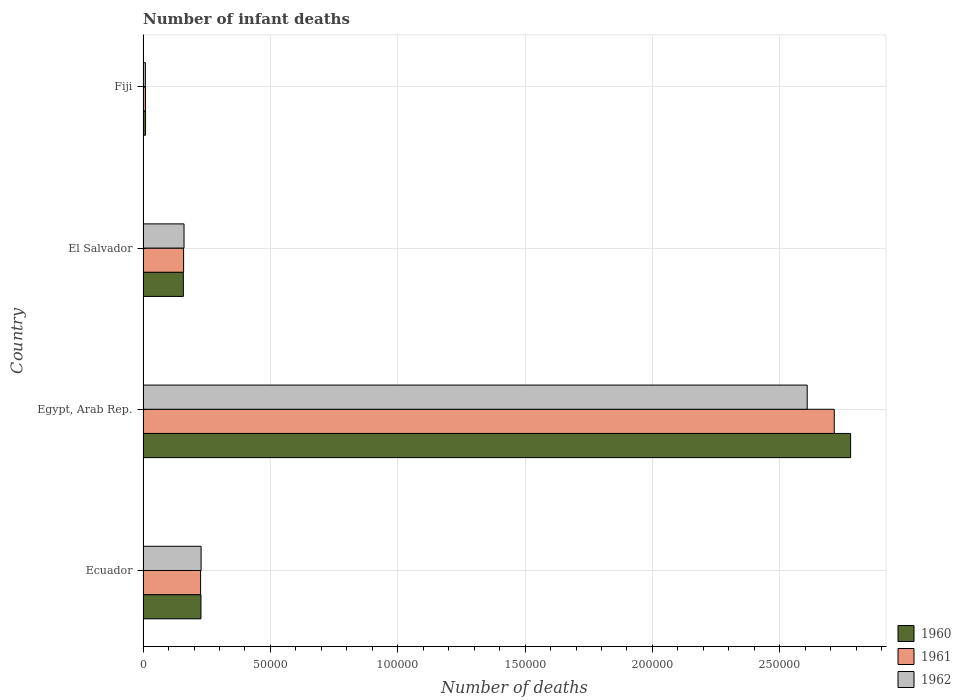How many different coloured bars are there?
Offer a very short reply. 3. Are the number of bars on each tick of the Y-axis equal?
Your answer should be very brief. Yes. How many bars are there on the 2nd tick from the top?
Offer a very short reply. 3. How many bars are there on the 1st tick from the bottom?
Your response must be concise. 3. What is the label of the 2nd group of bars from the top?
Keep it short and to the point. El Salvador. In how many cases, is the number of bars for a given country not equal to the number of legend labels?
Provide a short and direct response. 0. What is the number of infant deaths in 1962 in Fiji?
Your answer should be compact. 909. Across all countries, what is the maximum number of infant deaths in 1960?
Keep it short and to the point. 2.78e+05. Across all countries, what is the minimum number of infant deaths in 1960?
Give a very brief answer. 977. In which country was the number of infant deaths in 1961 maximum?
Ensure brevity in your answer.  Egypt, Arab Rep. In which country was the number of infant deaths in 1962 minimum?
Ensure brevity in your answer.  Fiji. What is the total number of infant deaths in 1960 in the graph?
Keep it short and to the point. 3.17e+05. What is the difference between the number of infant deaths in 1962 in Ecuador and that in Fiji?
Your answer should be very brief. 2.19e+04. What is the difference between the number of infant deaths in 1962 in El Salvador and the number of infant deaths in 1961 in Ecuador?
Your answer should be very brief. -6498. What is the average number of infant deaths in 1961 per country?
Provide a short and direct response. 7.77e+04. What is the difference between the number of infant deaths in 1962 and number of infant deaths in 1960 in Fiji?
Your response must be concise. -68. What is the ratio of the number of infant deaths in 1960 in Ecuador to that in Egypt, Arab Rep.?
Keep it short and to the point. 0.08. Is the difference between the number of infant deaths in 1962 in Egypt, Arab Rep. and Fiji greater than the difference between the number of infant deaths in 1960 in Egypt, Arab Rep. and Fiji?
Your answer should be very brief. No. What is the difference between the highest and the second highest number of infant deaths in 1960?
Provide a succinct answer. 2.55e+05. What is the difference between the highest and the lowest number of infant deaths in 1961?
Your answer should be compact. 2.70e+05. Is the sum of the number of infant deaths in 1961 in Ecuador and Egypt, Arab Rep. greater than the maximum number of infant deaths in 1962 across all countries?
Offer a very short reply. Yes. What does the 1st bar from the bottom in Egypt, Arab Rep. represents?
Offer a very short reply. 1960. Is it the case that in every country, the sum of the number of infant deaths in 1961 and number of infant deaths in 1962 is greater than the number of infant deaths in 1960?
Your answer should be compact. Yes. How many bars are there?
Keep it short and to the point. 12. Are all the bars in the graph horizontal?
Ensure brevity in your answer.  Yes. How many countries are there in the graph?
Provide a short and direct response. 4. Does the graph contain grids?
Keep it short and to the point. Yes. How are the legend labels stacked?
Ensure brevity in your answer.  Vertical. What is the title of the graph?
Ensure brevity in your answer.  Number of infant deaths. What is the label or title of the X-axis?
Offer a very short reply. Number of deaths. What is the Number of deaths of 1960 in Ecuador?
Provide a short and direct response. 2.27e+04. What is the Number of deaths in 1961 in Ecuador?
Make the answer very short. 2.26e+04. What is the Number of deaths of 1962 in Ecuador?
Make the answer very short. 2.28e+04. What is the Number of deaths in 1960 in Egypt, Arab Rep.?
Provide a short and direct response. 2.78e+05. What is the Number of deaths of 1961 in Egypt, Arab Rep.?
Ensure brevity in your answer.  2.71e+05. What is the Number of deaths in 1962 in Egypt, Arab Rep.?
Your answer should be very brief. 2.61e+05. What is the Number of deaths of 1960 in El Salvador?
Provide a succinct answer. 1.58e+04. What is the Number of deaths in 1961 in El Salvador?
Offer a very short reply. 1.59e+04. What is the Number of deaths in 1962 in El Salvador?
Provide a succinct answer. 1.61e+04. What is the Number of deaths in 1960 in Fiji?
Your response must be concise. 977. What is the Number of deaths in 1961 in Fiji?
Your answer should be very brief. 945. What is the Number of deaths of 1962 in Fiji?
Keep it short and to the point. 909. Across all countries, what is the maximum Number of deaths in 1960?
Offer a terse response. 2.78e+05. Across all countries, what is the maximum Number of deaths of 1961?
Your response must be concise. 2.71e+05. Across all countries, what is the maximum Number of deaths in 1962?
Ensure brevity in your answer.  2.61e+05. Across all countries, what is the minimum Number of deaths in 1960?
Your response must be concise. 977. Across all countries, what is the minimum Number of deaths in 1961?
Your response must be concise. 945. Across all countries, what is the minimum Number of deaths of 1962?
Ensure brevity in your answer.  909. What is the total Number of deaths in 1960 in the graph?
Your answer should be compact. 3.17e+05. What is the total Number of deaths of 1961 in the graph?
Your response must be concise. 3.11e+05. What is the total Number of deaths in 1962 in the graph?
Provide a succinct answer. 3.01e+05. What is the difference between the Number of deaths in 1960 in Ecuador and that in Egypt, Arab Rep.?
Ensure brevity in your answer.  -2.55e+05. What is the difference between the Number of deaths in 1961 in Ecuador and that in Egypt, Arab Rep.?
Give a very brief answer. -2.49e+05. What is the difference between the Number of deaths of 1962 in Ecuador and that in Egypt, Arab Rep.?
Offer a very short reply. -2.38e+05. What is the difference between the Number of deaths in 1960 in Ecuador and that in El Salvador?
Offer a very short reply. 6912. What is the difference between the Number of deaths of 1961 in Ecuador and that in El Salvador?
Provide a short and direct response. 6672. What is the difference between the Number of deaths of 1962 in Ecuador and that in El Salvador?
Give a very brief answer. 6700. What is the difference between the Number of deaths of 1960 in Ecuador and that in Fiji?
Give a very brief answer. 2.18e+04. What is the difference between the Number of deaths of 1961 in Ecuador and that in Fiji?
Offer a very short reply. 2.16e+04. What is the difference between the Number of deaths of 1962 in Ecuador and that in Fiji?
Offer a terse response. 2.19e+04. What is the difference between the Number of deaths of 1960 in Egypt, Arab Rep. and that in El Salvador?
Your response must be concise. 2.62e+05. What is the difference between the Number of deaths in 1961 in Egypt, Arab Rep. and that in El Salvador?
Your answer should be compact. 2.56e+05. What is the difference between the Number of deaths in 1962 in Egypt, Arab Rep. and that in El Salvador?
Offer a very short reply. 2.45e+05. What is the difference between the Number of deaths of 1960 in Egypt, Arab Rep. and that in Fiji?
Your response must be concise. 2.77e+05. What is the difference between the Number of deaths of 1961 in Egypt, Arab Rep. and that in Fiji?
Provide a short and direct response. 2.70e+05. What is the difference between the Number of deaths of 1962 in Egypt, Arab Rep. and that in Fiji?
Your answer should be compact. 2.60e+05. What is the difference between the Number of deaths of 1960 in El Salvador and that in Fiji?
Offer a terse response. 1.48e+04. What is the difference between the Number of deaths of 1961 in El Salvador and that in Fiji?
Provide a short and direct response. 1.50e+04. What is the difference between the Number of deaths of 1962 in El Salvador and that in Fiji?
Keep it short and to the point. 1.52e+04. What is the difference between the Number of deaths in 1960 in Ecuador and the Number of deaths in 1961 in Egypt, Arab Rep.?
Provide a short and direct response. -2.49e+05. What is the difference between the Number of deaths in 1960 in Ecuador and the Number of deaths in 1962 in Egypt, Arab Rep.?
Ensure brevity in your answer.  -2.38e+05. What is the difference between the Number of deaths of 1961 in Ecuador and the Number of deaths of 1962 in Egypt, Arab Rep.?
Make the answer very short. -2.38e+05. What is the difference between the Number of deaths of 1960 in Ecuador and the Number of deaths of 1961 in El Salvador?
Keep it short and to the point. 6815. What is the difference between the Number of deaths of 1960 in Ecuador and the Number of deaths of 1962 in El Salvador?
Give a very brief answer. 6641. What is the difference between the Number of deaths in 1961 in Ecuador and the Number of deaths in 1962 in El Salvador?
Keep it short and to the point. 6498. What is the difference between the Number of deaths in 1960 in Ecuador and the Number of deaths in 1961 in Fiji?
Make the answer very short. 2.18e+04. What is the difference between the Number of deaths in 1960 in Ecuador and the Number of deaths in 1962 in Fiji?
Make the answer very short. 2.18e+04. What is the difference between the Number of deaths of 1961 in Ecuador and the Number of deaths of 1962 in Fiji?
Make the answer very short. 2.17e+04. What is the difference between the Number of deaths of 1960 in Egypt, Arab Rep. and the Number of deaths of 1961 in El Salvador?
Your answer should be very brief. 2.62e+05. What is the difference between the Number of deaths in 1960 in Egypt, Arab Rep. and the Number of deaths in 1962 in El Salvador?
Ensure brevity in your answer.  2.62e+05. What is the difference between the Number of deaths in 1961 in Egypt, Arab Rep. and the Number of deaths in 1962 in El Salvador?
Ensure brevity in your answer.  2.55e+05. What is the difference between the Number of deaths of 1960 in Egypt, Arab Rep. and the Number of deaths of 1961 in Fiji?
Your response must be concise. 2.77e+05. What is the difference between the Number of deaths in 1960 in Egypt, Arab Rep. and the Number of deaths in 1962 in Fiji?
Provide a short and direct response. 2.77e+05. What is the difference between the Number of deaths in 1961 in Egypt, Arab Rep. and the Number of deaths in 1962 in Fiji?
Your answer should be compact. 2.71e+05. What is the difference between the Number of deaths in 1960 in El Salvador and the Number of deaths in 1961 in Fiji?
Ensure brevity in your answer.  1.49e+04. What is the difference between the Number of deaths in 1960 in El Salvador and the Number of deaths in 1962 in Fiji?
Your answer should be compact. 1.49e+04. What is the difference between the Number of deaths of 1961 in El Salvador and the Number of deaths of 1962 in Fiji?
Offer a very short reply. 1.50e+04. What is the average Number of deaths of 1960 per country?
Your answer should be compact. 7.93e+04. What is the average Number of deaths of 1961 per country?
Give a very brief answer. 7.77e+04. What is the average Number of deaths of 1962 per country?
Offer a terse response. 7.51e+04. What is the difference between the Number of deaths of 1960 and Number of deaths of 1961 in Ecuador?
Keep it short and to the point. 143. What is the difference between the Number of deaths in 1960 and Number of deaths in 1962 in Ecuador?
Keep it short and to the point. -59. What is the difference between the Number of deaths in 1961 and Number of deaths in 1962 in Ecuador?
Your answer should be very brief. -202. What is the difference between the Number of deaths of 1960 and Number of deaths of 1961 in Egypt, Arab Rep.?
Keep it short and to the point. 6414. What is the difference between the Number of deaths of 1960 and Number of deaths of 1962 in Egypt, Arab Rep.?
Offer a terse response. 1.70e+04. What is the difference between the Number of deaths in 1961 and Number of deaths in 1962 in Egypt, Arab Rep.?
Your response must be concise. 1.06e+04. What is the difference between the Number of deaths in 1960 and Number of deaths in 1961 in El Salvador?
Make the answer very short. -97. What is the difference between the Number of deaths of 1960 and Number of deaths of 1962 in El Salvador?
Provide a short and direct response. -271. What is the difference between the Number of deaths of 1961 and Number of deaths of 1962 in El Salvador?
Offer a very short reply. -174. What is the difference between the Number of deaths of 1960 and Number of deaths of 1961 in Fiji?
Ensure brevity in your answer.  32. What is the ratio of the Number of deaths in 1960 in Ecuador to that in Egypt, Arab Rep.?
Your response must be concise. 0.08. What is the ratio of the Number of deaths of 1961 in Ecuador to that in Egypt, Arab Rep.?
Provide a short and direct response. 0.08. What is the ratio of the Number of deaths of 1962 in Ecuador to that in Egypt, Arab Rep.?
Your answer should be very brief. 0.09. What is the ratio of the Number of deaths of 1960 in Ecuador to that in El Salvador?
Keep it short and to the point. 1.44. What is the ratio of the Number of deaths in 1961 in Ecuador to that in El Salvador?
Provide a short and direct response. 1.42. What is the ratio of the Number of deaths of 1962 in Ecuador to that in El Salvador?
Your answer should be very brief. 1.42. What is the ratio of the Number of deaths in 1960 in Ecuador to that in Fiji?
Provide a short and direct response. 23.27. What is the ratio of the Number of deaths of 1961 in Ecuador to that in Fiji?
Ensure brevity in your answer.  23.9. What is the ratio of the Number of deaths in 1962 in Ecuador to that in Fiji?
Ensure brevity in your answer.  25.07. What is the ratio of the Number of deaths in 1960 in Egypt, Arab Rep. to that in El Salvador?
Your answer should be compact. 17.56. What is the ratio of the Number of deaths in 1961 in Egypt, Arab Rep. to that in El Salvador?
Keep it short and to the point. 17.05. What is the ratio of the Number of deaths of 1962 in Egypt, Arab Rep. to that in El Salvador?
Provide a short and direct response. 16.21. What is the ratio of the Number of deaths in 1960 in Egypt, Arab Rep. to that in Fiji?
Give a very brief answer. 284.38. What is the ratio of the Number of deaths of 1961 in Egypt, Arab Rep. to that in Fiji?
Give a very brief answer. 287.22. What is the ratio of the Number of deaths in 1962 in Egypt, Arab Rep. to that in Fiji?
Provide a short and direct response. 286.9. What is the ratio of the Number of deaths in 1960 in El Salvador to that in Fiji?
Give a very brief answer. 16.19. What is the ratio of the Number of deaths in 1961 in El Salvador to that in Fiji?
Offer a very short reply. 16.84. What is the ratio of the Number of deaths of 1962 in El Salvador to that in Fiji?
Your answer should be compact. 17.7. What is the difference between the highest and the second highest Number of deaths of 1960?
Keep it short and to the point. 2.55e+05. What is the difference between the highest and the second highest Number of deaths of 1961?
Your response must be concise. 2.49e+05. What is the difference between the highest and the second highest Number of deaths of 1962?
Your answer should be very brief. 2.38e+05. What is the difference between the highest and the lowest Number of deaths in 1960?
Offer a terse response. 2.77e+05. What is the difference between the highest and the lowest Number of deaths in 1961?
Your answer should be very brief. 2.70e+05. What is the difference between the highest and the lowest Number of deaths in 1962?
Your answer should be very brief. 2.60e+05. 